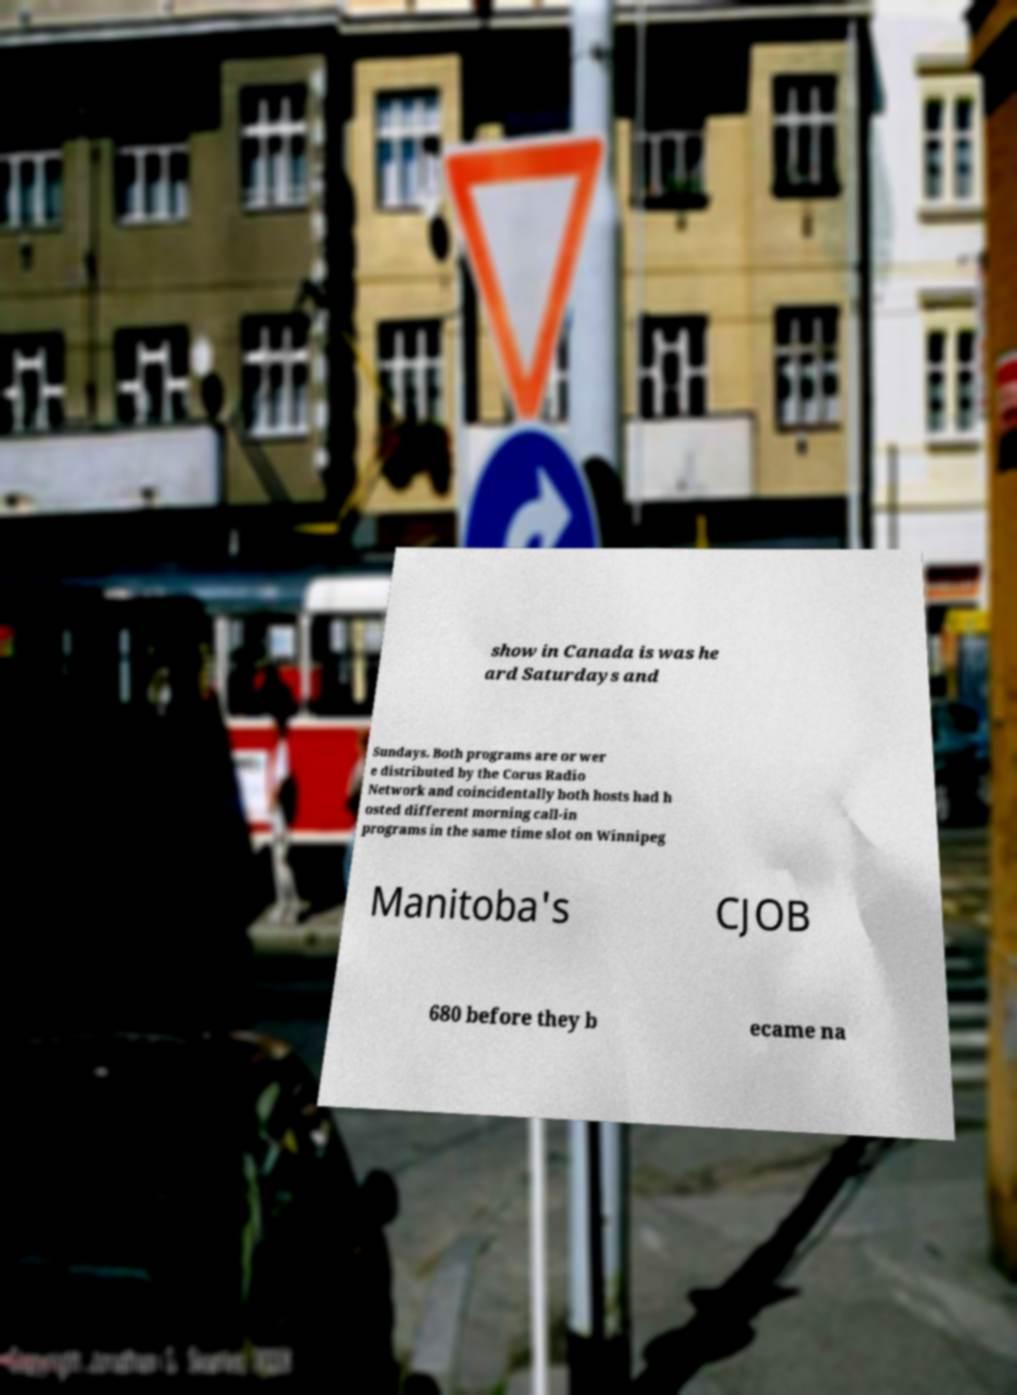Can you read and provide the text displayed in the image?This photo seems to have some interesting text. Can you extract and type it out for me? show in Canada is was he ard Saturdays and Sundays. Both programs are or wer e distributed by the Corus Radio Network and coincidentally both hosts had h osted different morning call-in programs in the same time slot on Winnipeg Manitoba's CJOB 680 before they b ecame na 